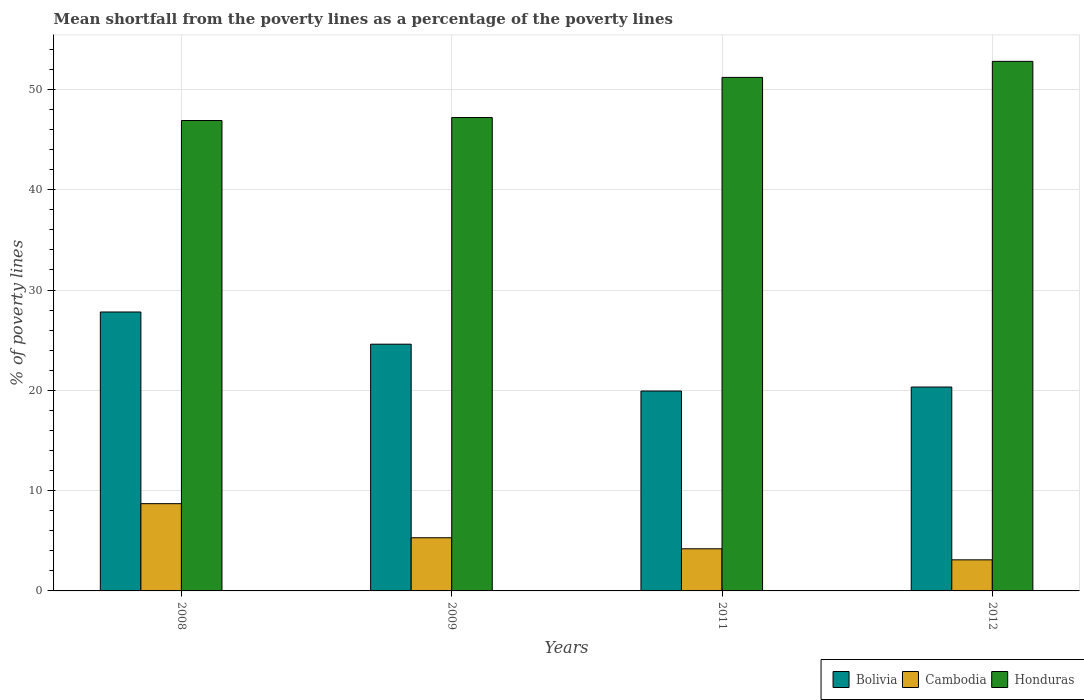How many different coloured bars are there?
Make the answer very short. 3. How many groups of bars are there?
Your response must be concise. 4. Are the number of bars per tick equal to the number of legend labels?
Offer a very short reply. Yes. Are the number of bars on each tick of the X-axis equal?
Offer a terse response. Yes. How many bars are there on the 3rd tick from the right?
Give a very brief answer. 3. In how many cases, is the number of bars for a given year not equal to the number of legend labels?
Your response must be concise. 0. What is the mean shortfall from the poverty lines as a percentage of the poverty lines in Bolivia in 2011?
Make the answer very short. 19.93. Across all years, what is the maximum mean shortfall from the poverty lines as a percentage of the poverty lines in Bolivia?
Keep it short and to the point. 27.81. Across all years, what is the minimum mean shortfall from the poverty lines as a percentage of the poverty lines in Honduras?
Make the answer very short. 46.9. What is the total mean shortfall from the poverty lines as a percentage of the poverty lines in Honduras in the graph?
Your response must be concise. 198.1. What is the difference between the mean shortfall from the poverty lines as a percentage of the poverty lines in Bolivia in 2008 and that in 2012?
Provide a succinct answer. 7.48. What is the difference between the mean shortfall from the poverty lines as a percentage of the poverty lines in Bolivia in 2011 and the mean shortfall from the poverty lines as a percentage of the poverty lines in Honduras in 2008?
Offer a very short reply. -26.97. What is the average mean shortfall from the poverty lines as a percentage of the poverty lines in Honduras per year?
Ensure brevity in your answer.  49.53. In the year 2012, what is the difference between the mean shortfall from the poverty lines as a percentage of the poverty lines in Honduras and mean shortfall from the poverty lines as a percentage of the poverty lines in Bolivia?
Keep it short and to the point. 32.47. In how many years, is the mean shortfall from the poverty lines as a percentage of the poverty lines in Honduras greater than 14 %?
Make the answer very short. 4. What is the ratio of the mean shortfall from the poverty lines as a percentage of the poverty lines in Bolivia in 2008 to that in 2012?
Give a very brief answer. 1.37. Is the difference between the mean shortfall from the poverty lines as a percentage of the poverty lines in Honduras in 2011 and 2012 greater than the difference between the mean shortfall from the poverty lines as a percentage of the poverty lines in Bolivia in 2011 and 2012?
Provide a succinct answer. No. What is the difference between the highest and the second highest mean shortfall from the poverty lines as a percentage of the poverty lines in Honduras?
Keep it short and to the point. 1.6. What is the difference between the highest and the lowest mean shortfall from the poverty lines as a percentage of the poverty lines in Cambodia?
Offer a terse response. 5.6. In how many years, is the mean shortfall from the poverty lines as a percentage of the poverty lines in Bolivia greater than the average mean shortfall from the poverty lines as a percentage of the poverty lines in Bolivia taken over all years?
Provide a succinct answer. 2. Is the sum of the mean shortfall from the poverty lines as a percentage of the poverty lines in Cambodia in 2008 and 2012 greater than the maximum mean shortfall from the poverty lines as a percentage of the poverty lines in Bolivia across all years?
Provide a short and direct response. No. What does the 2nd bar from the left in 2008 represents?
Provide a succinct answer. Cambodia. What does the 2nd bar from the right in 2008 represents?
Provide a short and direct response. Cambodia. Is it the case that in every year, the sum of the mean shortfall from the poverty lines as a percentage of the poverty lines in Honduras and mean shortfall from the poverty lines as a percentage of the poverty lines in Bolivia is greater than the mean shortfall from the poverty lines as a percentage of the poverty lines in Cambodia?
Keep it short and to the point. Yes. Are the values on the major ticks of Y-axis written in scientific E-notation?
Offer a very short reply. No. Does the graph contain any zero values?
Provide a short and direct response. No. Does the graph contain grids?
Provide a short and direct response. Yes. What is the title of the graph?
Provide a short and direct response. Mean shortfall from the poverty lines as a percentage of the poverty lines. Does "Turkey" appear as one of the legend labels in the graph?
Offer a terse response. No. What is the label or title of the Y-axis?
Give a very brief answer. % of poverty lines. What is the % of poverty lines in Bolivia in 2008?
Your answer should be compact. 27.81. What is the % of poverty lines in Cambodia in 2008?
Offer a terse response. 8.7. What is the % of poverty lines in Honduras in 2008?
Give a very brief answer. 46.9. What is the % of poverty lines in Bolivia in 2009?
Offer a very short reply. 24.6. What is the % of poverty lines of Honduras in 2009?
Your response must be concise. 47.2. What is the % of poverty lines in Bolivia in 2011?
Your answer should be very brief. 19.93. What is the % of poverty lines of Honduras in 2011?
Ensure brevity in your answer.  51.2. What is the % of poverty lines in Bolivia in 2012?
Your response must be concise. 20.33. What is the % of poverty lines in Honduras in 2012?
Offer a very short reply. 52.8. Across all years, what is the maximum % of poverty lines of Bolivia?
Offer a terse response. 27.81. Across all years, what is the maximum % of poverty lines in Honduras?
Make the answer very short. 52.8. Across all years, what is the minimum % of poverty lines in Bolivia?
Your response must be concise. 19.93. Across all years, what is the minimum % of poverty lines of Cambodia?
Provide a succinct answer. 3.1. Across all years, what is the minimum % of poverty lines in Honduras?
Your response must be concise. 46.9. What is the total % of poverty lines of Bolivia in the graph?
Offer a very short reply. 92.67. What is the total % of poverty lines in Cambodia in the graph?
Provide a short and direct response. 21.3. What is the total % of poverty lines in Honduras in the graph?
Provide a short and direct response. 198.1. What is the difference between the % of poverty lines of Bolivia in 2008 and that in 2009?
Provide a succinct answer. 3.21. What is the difference between the % of poverty lines of Honduras in 2008 and that in 2009?
Give a very brief answer. -0.3. What is the difference between the % of poverty lines in Bolivia in 2008 and that in 2011?
Give a very brief answer. 7.88. What is the difference between the % of poverty lines in Honduras in 2008 and that in 2011?
Your answer should be very brief. -4.3. What is the difference between the % of poverty lines in Bolivia in 2008 and that in 2012?
Make the answer very short. 7.48. What is the difference between the % of poverty lines in Cambodia in 2008 and that in 2012?
Give a very brief answer. 5.6. What is the difference between the % of poverty lines in Honduras in 2008 and that in 2012?
Your response must be concise. -5.9. What is the difference between the % of poverty lines in Bolivia in 2009 and that in 2011?
Provide a short and direct response. 4.67. What is the difference between the % of poverty lines in Bolivia in 2009 and that in 2012?
Keep it short and to the point. 4.27. What is the difference between the % of poverty lines of Cambodia in 2009 and that in 2012?
Offer a terse response. 2.2. What is the difference between the % of poverty lines of Honduras in 2009 and that in 2012?
Your answer should be compact. -5.6. What is the difference between the % of poverty lines in Bolivia in 2008 and the % of poverty lines in Cambodia in 2009?
Ensure brevity in your answer.  22.51. What is the difference between the % of poverty lines in Bolivia in 2008 and the % of poverty lines in Honduras in 2009?
Make the answer very short. -19.39. What is the difference between the % of poverty lines in Cambodia in 2008 and the % of poverty lines in Honduras in 2009?
Provide a succinct answer. -38.5. What is the difference between the % of poverty lines in Bolivia in 2008 and the % of poverty lines in Cambodia in 2011?
Your answer should be very brief. 23.61. What is the difference between the % of poverty lines of Bolivia in 2008 and the % of poverty lines of Honduras in 2011?
Give a very brief answer. -23.39. What is the difference between the % of poverty lines in Cambodia in 2008 and the % of poverty lines in Honduras in 2011?
Make the answer very short. -42.5. What is the difference between the % of poverty lines in Bolivia in 2008 and the % of poverty lines in Cambodia in 2012?
Your answer should be compact. 24.71. What is the difference between the % of poverty lines in Bolivia in 2008 and the % of poverty lines in Honduras in 2012?
Offer a very short reply. -24.99. What is the difference between the % of poverty lines of Cambodia in 2008 and the % of poverty lines of Honduras in 2012?
Make the answer very short. -44.1. What is the difference between the % of poverty lines in Bolivia in 2009 and the % of poverty lines in Cambodia in 2011?
Give a very brief answer. 20.4. What is the difference between the % of poverty lines of Bolivia in 2009 and the % of poverty lines of Honduras in 2011?
Your answer should be compact. -26.6. What is the difference between the % of poverty lines of Cambodia in 2009 and the % of poverty lines of Honduras in 2011?
Your answer should be very brief. -45.9. What is the difference between the % of poverty lines in Bolivia in 2009 and the % of poverty lines in Honduras in 2012?
Your answer should be very brief. -28.2. What is the difference between the % of poverty lines of Cambodia in 2009 and the % of poverty lines of Honduras in 2012?
Your answer should be compact. -47.5. What is the difference between the % of poverty lines in Bolivia in 2011 and the % of poverty lines in Cambodia in 2012?
Your answer should be compact. 16.83. What is the difference between the % of poverty lines in Bolivia in 2011 and the % of poverty lines in Honduras in 2012?
Provide a short and direct response. -32.87. What is the difference between the % of poverty lines of Cambodia in 2011 and the % of poverty lines of Honduras in 2012?
Give a very brief answer. -48.6. What is the average % of poverty lines of Bolivia per year?
Offer a very short reply. 23.17. What is the average % of poverty lines in Cambodia per year?
Provide a succinct answer. 5.33. What is the average % of poverty lines of Honduras per year?
Your response must be concise. 49.52. In the year 2008, what is the difference between the % of poverty lines in Bolivia and % of poverty lines in Cambodia?
Your answer should be compact. 19.11. In the year 2008, what is the difference between the % of poverty lines of Bolivia and % of poverty lines of Honduras?
Give a very brief answer. -19.09. In the year 2008, what is the difference between the % of poverty lines in Cambodia and % of poverty lines in Honduras?
Ensure brevity in your answer.  -38.2. In the year 2009, what is the difference between the % of poverty lines in Bolivia and % of poverty lines in Cambodia?
Keep it short and to the point. 19.3. In the year 2009, what is the difference between the % of poverty lines of Bolivia and % of poverty lines of Honduras?
Provide a succinct answer. -22.6. In the year 2009, what is the difference between the % of poverty lines of Cambodia and % of poverty lines of Honduras?
Your response must be concise. -41.9. In the year 2011, what is the difference between the % of poverty lines in Bolivia and % of poverty lines in Cambodia?
Keep it short and to the point. 15.73. In the year 2011, what is the difference between the % of poverty lines of Bolivia and % of poverty lines of Honduras?
Provide a short and direct response. -31.27. In the year 2011, what is the difference between the % of poverty lines of Cambodia and % of poverty lines of Honduras?
Offer a very short reply. -47. In the year 2012, what is the difference between the % of poverty lines in Bolivia and % of poverty lines in Cambodia?
Keep it short and to the point. 17.23. In the year 2012, what is the difference between the % of poverty lines of Bolivia and % of poverty lines of Honduras?
Make the answer very short. -32.47. In the year 2012, what is the difference between the % of poverty lines in Cambodia and % of poverty lines in Honduras?
Your response must be concise. -49.7. What is the ratio of the % of poverty lines of Bolivia in 2008 to that in 2009?
Provide a short and direct response. 1.13. What is the ratio of the % of poverty lines of Cambodia in 2008 to that in 2009?
Your response must be concise. 1.64. What is the ratio of the % of poverty lines in Honduras in 2008 to that in 2009?
Offer a terse response. 0.99. What is the ratio of the % of poverty lines in Bolivia in 2008 to that in 2011?
Offer a terse response. 1.4. What is the ratio of the % of poverty lines of Cambodia in 2008 to that in 2011?
Make the answer very short. 2.07. What is the ratio of the % of poverty lines in Honduras in 2008 to that in 2011?
Give a very brief answer. 0.92. What is the ratio of the % of poverty lines in Bolivia in 2008 to that in 2012?
Your response must be concise. 1.37. What is the ratio of the % of poverty lines of Cambodia in 2008 to that in 2012?
Your answer should be very brief. 2.81. What is the ratio of the % of poverty lines in Honduras in 2008 to that in 2012?
Your answer should be very brief. 0.89. What is the ratio of the % of poverty lines of Bolivia in 2009 to that in 2011?
Keep it short and to the point. 1.23. What is the ratio of the % of poverty lines in Cambodia in 2009 to that in 2011?
Make the answer very short. 1.26. What is the ratio of the % of poverty lines of Honduras in 2009 to that in 2011?
Your answer should be very brief. 0.92. What is the ratio of the % of poverty lines in Bolivia in 2009 to that in 2012?
Ensure brevity in your answer.  1.21. What is the ratio of the % of poverty lines in Cambodia in 2009 to that in 2012?
Make the answer very short. 1.71. What is the ratio of the % of poverty lines in Honduras in 2009 to that in 2012?
Provide a short and direct response. 0.89. What is the ratio of the % of poverty lines of Bolivia in 2011 to that in 2012?
Your answer should be very brief. 0.98. What is the ratio of the % of poverty lines of Cambodia in 2011 to that in 2012?
Your answer should be very brief. 1.35. What is the ratio of the % of poverty lines in Honduras in 2011 to that in 2012?
Your answer should be compact. 0.97. What is the difference between the highest and the second highest % of poverty lines of Bolivia?
Ensure brevity in your answer.  3.21. What is the difference between the highest and the second highest % of poverty lines of Cambodia?
Your answer should be compact. 3.4. What is the difference between the highest and the lowest % of poverty lines of Bolivia?
Provide a succinct answer. 7.88. 